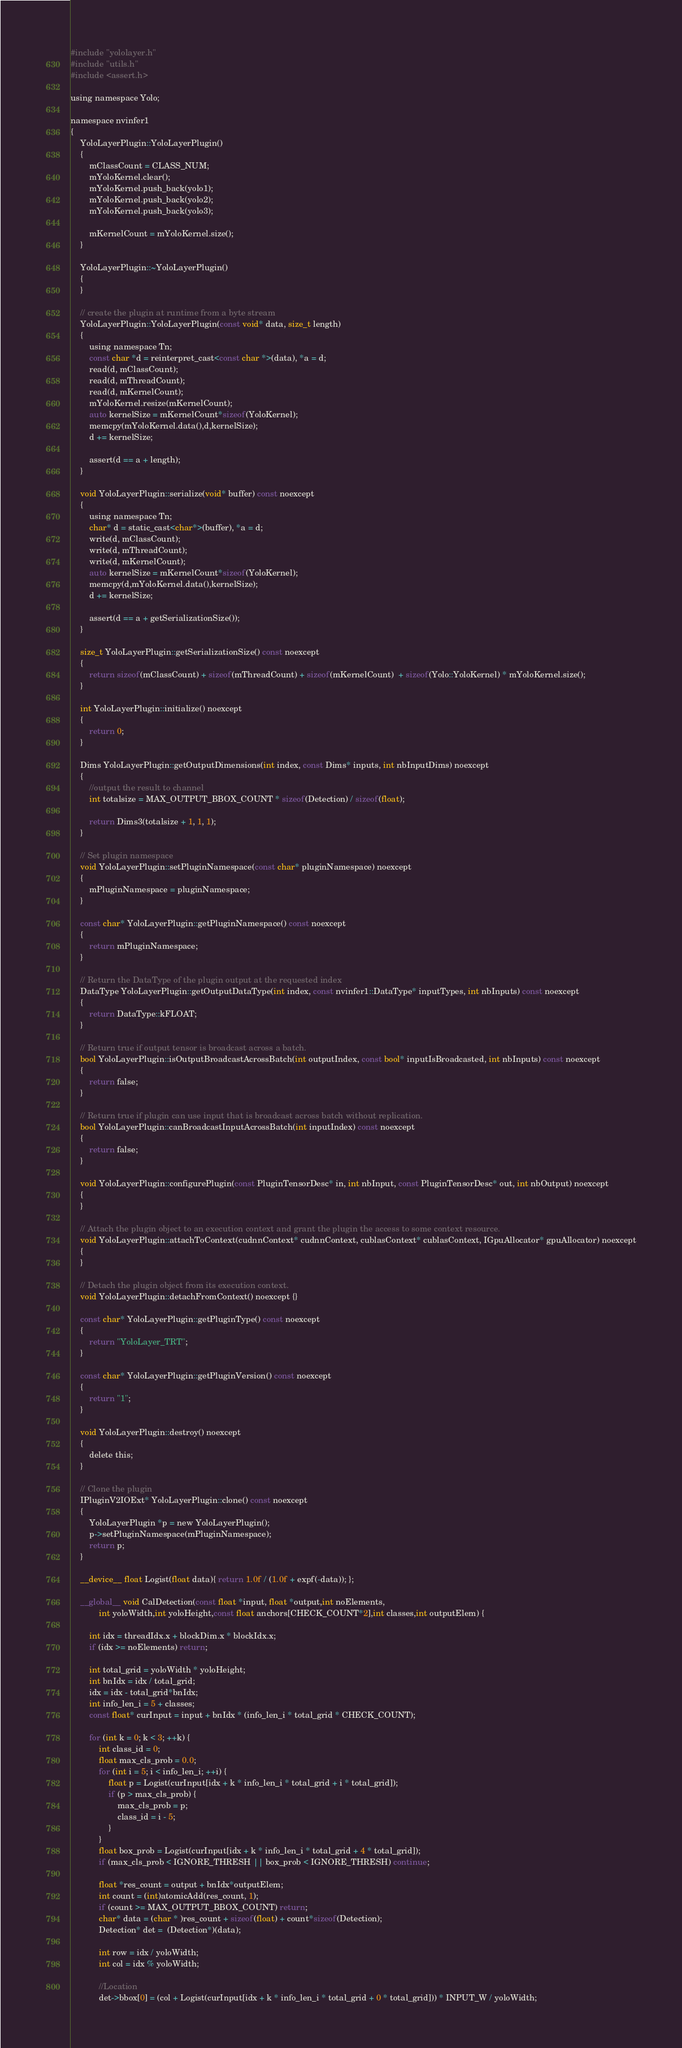Convert code to text. <code><loc_0><loc_0><loc_500><loc_500><_Cuda_>#include "yololayer.h"
#include "utils.h"
#include <assert.h>

using namespace Yolo;

namespace nvinfer1
{
    YoloLayerPlugin::YoloLayerPlugin()
    {
        mClassCount = CLASS_NUM;
        mYoloKernel.clear();
        mYoloKernel.push_back(yolo1);
        mYoloKernel.push_back(yolo2);
        mYoloKernel.push_back(yolo3);

        mKernelCount = mYoloKernel.size();
    }
    
    YoloLayerPlugin::~YoloLayerPlugin()
    {
    }

    // create the plugin at runtime from a byte stream
    YoloLayerPlugin::YoloLayerPlugin(const void* data, size_t length)
    {
        using namespace Tn;
        const char *d = reinterpret_cast<const char *>(data), *a = d;
        read(d, mClassCount);
        read(d, mThreadCount);
        read(d, mKernelCount);
        mYoloKernel.resize(mKernelCount);
        auto kernelSize = mKernelCount*sizeof(YoloKernel);
        memcpy(mYoloKernel.data(),d,kernelSize);
        d += kernelSize;

        assert(d == a + length);
    }

    void YoloLayerPlugin::serialize(void* buffer) const noexcept
    {
        using namespace Tn;
        char* d = static_cast<char*>(buffer), *a = d;
        write(d, mClassCount);
        write(d, mThreadCount);
        write(d, mKernelCount);
        auto kernelSize = mKernelCount*sizeof(YoloKernel);
        memcpy(d,mYoloKernel.data(),kernelSize);
        d += kernelSize;

        assert(d == a + getSerializationSize());
    }
    
    size_t YoloLayerPlugin::getSerializationSize() const noexcept
    {  
        return sizeof(mClassCount) + sizeof(mThreadCount) + sizeof(mKernelCount)  + sizeof(Yolo::YoloKernel) * mYoloKernel.size();
    }

    int YoloLayerPlugin::initialize() noexcept
    { 
        return 0;
    }
    
    Dims YoloLayerPlugin::getOutputDimensions(int index, const Dims* inputs, int nbInputDims) noexcept
    {
        //output the result to channel
        int totalsize = MAX_OUTPUT_BBOX_COUNT * sizeof(Detection) / sizeof(float);

        return Dims3(totalsize + 1, 1, 1);
    }

    // Set plugin namespace
    void YoloLayerPlugin::setPluginNamespace(const char* pluginNamespace) noexcept
    {
        mPluginNamespace = pluginNamespace;
    }

    const char* YoloLayerPlugin::getPluginNamespace() const noexcept
    {
        return mPluginNamespace;
    }

    // Return the DataType of the plugin output at the requested index
    DataType YoloLayerPlugin::getOutputDataType(int index, const nvinfer1::DataType* inputTypes, int nbInputs) const noexcept
    {
        return DataType::kFLOAT;
    }

    // Return true if output tensor is broadcast across a batch.
    bool YoloLayerPlugin::isOutputBroadcastAcrossBatch(int outputIndex, const bool* inputIsBroadcasted, int nbInputs) const noexcept
    {
        return false;
    }

    // Return true if plugin can use input that is broadcast across batch without replication.
    bool YoloLayerPlugin::canBroadcastInputAcrossBatch(int inputIndex) const noexcept
    {
        return false;
    }

    void YoloLayerPlugin::configurePlugin(const PluginTensorDesc* in, int nbInput, const PluginTensorDesc* out, int nbOutput) noexcept
    {
    }

    // Attach the plugin object to an execution context and grant the plugin the access to some context resource.
    void YoloLayerPlugin::attachToContext(cudnnContext* cudnnContext, cublasContext* cublasContext, IGpuAllocator* gpuAllocator) noexcept
    {
    }

    // Detach the plugin object from its execution context.
    void YoloLayerPlugin::detachFromContext() noexcept {}

    const char* YoloLayerPlugin::getPluginType() const noexcept
    {
        return "YoloLayer_TRT";
    }

    const char* YoloLayerPlugin::getPluginVersion() const noexcept
    {
        return "1";
    }

    void YoloLayerPlugin::destroy() noexcept
    {
        delete this;
    }

    // Clone the plugin
    IPluginV2IOExt* YoloLayerPlugin::clone() const noexcept
    {
        YoloLayerPlugin *p = new YoloLayerPlugin();
        p->setPluginNamespace(mPluginNamespace);
        return p;
    }

    __device__ float Logist(float data){ return 1.0f / (1.0f + expf(-data)); };

    __global__ void CalDetection(const float *input, float *output,int noElements, 
            int yoloWidth,int yoloHeight,const float anchors[CHECK_COUNT*2],int classes,int outputElem) {
 
        int idx = threadIdx.x + blockDim.x * blockIdx.x;
        if (idx >= noElements) return;

        int total_grid = yoloWidth * yoloHeight;
        int bnIdx = idx / total_grid;
        idx = idx - total_grid*bnIdx;
        int info_len_i = 5 + classes;
        const float* curInput = input + bnIdx * (info_len_i * total_grid * CHECK_COUNT);

        for (int k = 0; k < 3; ++k) {
            int class_id = 0;
            float max_cls_prob = 0.0;
            for (int i = 5; i < info_len_i; ++i) {
                float p = Logist(curInput[idx + k * info_len_i * total_grid + i * total_grid]);
                if (p > max_cls_prob) {
                    max_cls_prob = p;
                    class_id = i - 5;
                }
            }
            float box_prob = Logist(curInput[idx + k * info_len_i * total_grid + 4 * total_grid]);
            if (max_cls_prob < IGNORE_THRESH || box_prob < IGNORE_THRESH) continue;

            float *res_count = output + bnIdx*outputElem;
            int count = (int)atomicAdd(res_count, 1);
            if (count >= MAX_OUTPUT_BBOX_COUNT) return;
            char* data = (char * )res_count + sizeof(float) + count*sizeof(Detection);
            Detection* det =  (Detection*)(data);

            int row = idx / yoloWidth;
            int col = idx % yoloWidth;

            //Location
            det->bbox[0] = (col + Logist(curInput[idx + k * info_len_i * total_grid + 0 * total_grid])) * INPUT_W / yoloWidth;</code> 